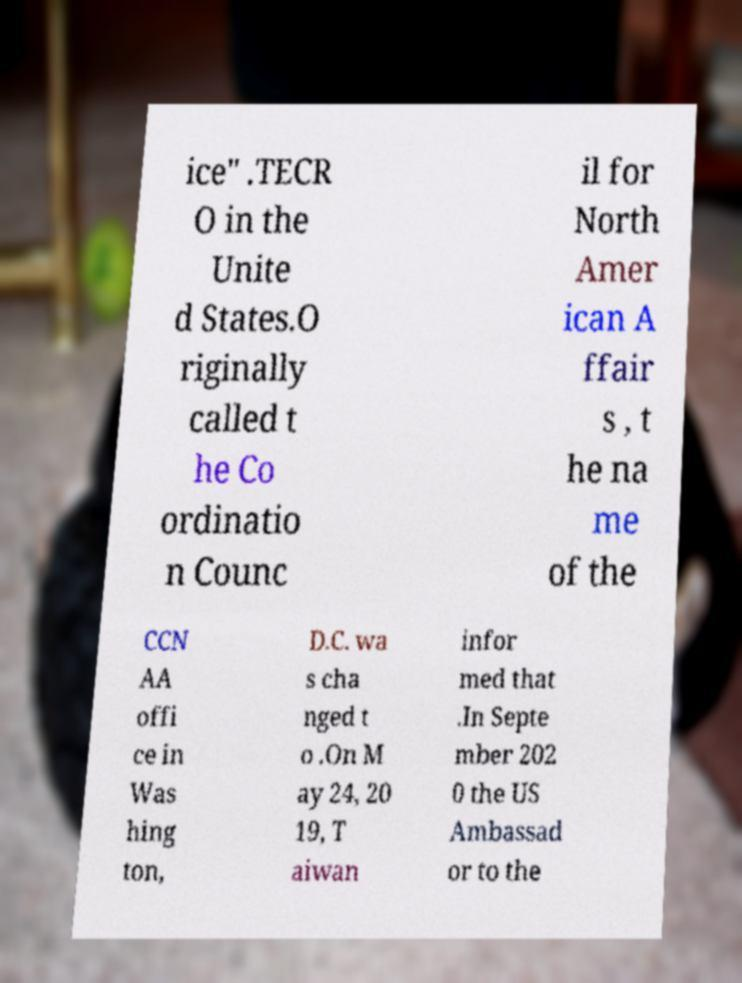For documentation purposes, I need the text within this image transcribed. Could you provide that? ice" .TECR O in the Unite d States.O riginally called t he Co ordinatio n Counc il for North Amer ican A ffair s , t he na me of the CCN AA offi ce in Was hing ton, D.C. wa s cha nged t o .On M ay 24, 20 19, T aiwan infor med that .In Septe mber 202 0 the US Ambassad or to the 